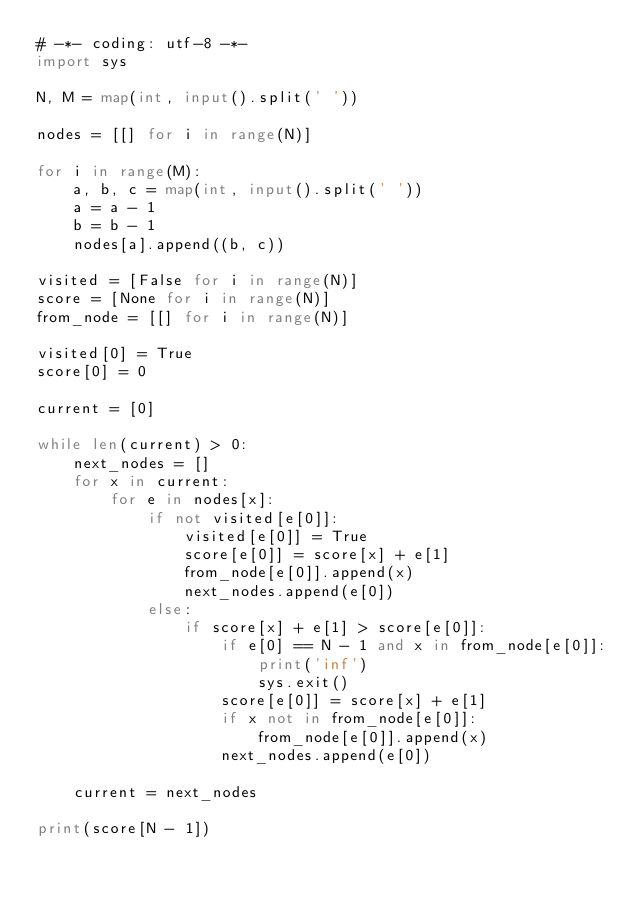<code> <loc_0><loc_0><loc_500><loc_500><_Python_># -*- coding: utf-8 -*-
import sys

N, M = map(int, input().split(' '))

nodes = [[] for i in range(N)]

for i in range(M):
    a, b, c = map(int, input().split(' '))
    a = a - 1
    b = b - 1
    nodes[a].append((b, c))

visited = [False for i in range(N)]
score = [None for i in range(N)]
from_node = [[] for i in range(N)]

visited[0] = True
score[0] = 0

current = [0]

while len(current) > 0:
    next_nodes = []
    for x in current:
        for e in nodes[x]:
            if not visited[e[0]]:
                visited[e[0]] = True
                score[e[0]] = score[x] + e[1]
                from_node[e[0]].append(x)
                next_nodes.append(e[0])
            else:
                if score[x] + e[1] > score[e[0]]:
                    if e[0] == N - 1 and x in from_node[e[0]]:
                        print('inf')
                        sys.exit()
                    score[e[0]] = score[x] + e[1]
                    if x not in from_node[e[0]]:
                        from_node[e[0]].append(x)
                    next_nodes.append(e[0])

    current = next_nodes

print(score[N - 1])
</code> 